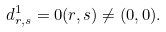Convert formula to latex. <formula><loc_0><loc_0><loc_500><loc_500>d ^ { 1 } _ { r , s } = 0 ( r , s ) \ne ( 0 , 0 ) .</formula> 